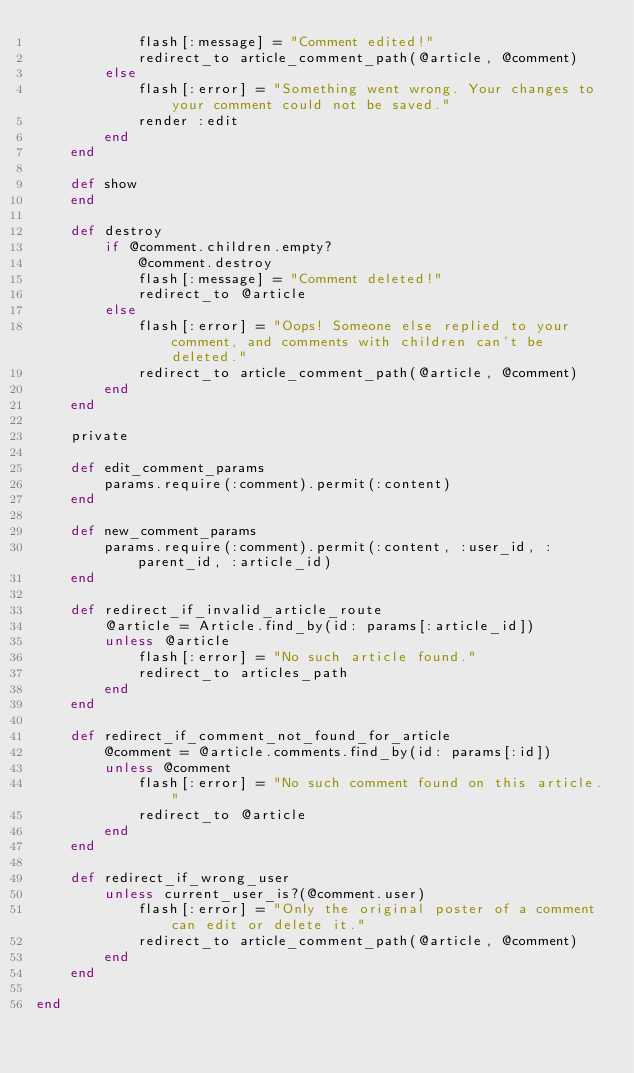Convert code to text. <code><loc_0><loc_0><loc_500><loc_500><_Ruby_>            flash[:message] = "Comment edited!"
            redirect_to article_comment_path(@article, @comment)
        else
            flash[:error] = "Something went wrong. Your changes to your comment could not be saved."
            render :edit
        end
    end

    def show
    end

    def destroy
        if @comment.children.empty?
            @comment.destroy
            flash[:message] = "Comment deleted!"
            redirect_to @article
        else
            flash[:error] = "Oops! Someone else replied to your comment, and comments with children can't be deleted."
            redirect_to article_comment_path(@article, @comment)
        end
    end

    private

    def edit_comment_params
        params.require(:comment).permit(:content)
    end

    def new_comment_params
        params.require(:comment).permit(:content, :user_id, :parent_id, :article_id)
    end

    def redirect_if_invalid_article_route
        @article = Article.find_by(id: params[:article_id])
        unless @article
            flash[:error] = "No such article found."
            redirect_to articles_path
        end
    end

    def redirect_if_comment_not_found_for_article
        @comment = @article.comments.find_by(id: params[:id])
        unless @comment
            flash[:error] = "No such comment found on this article."
            redirect_to @article
        end
    end

    def redirect_if_wrong_user
        unless current_user_is?(@comment.user)
            flash[:error] = "Only the original poster of a comment can edit or delete it."
            redirect_to article_comment_path(@article, @comment)
        end
    end

end
</code> 